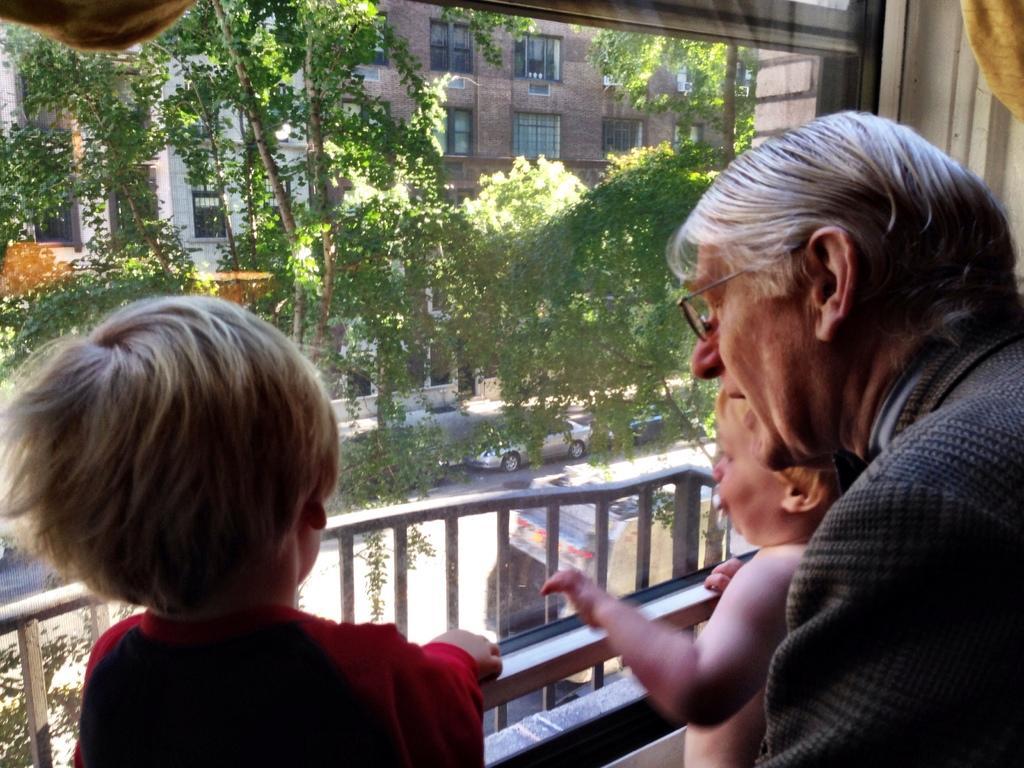In one or two sentences, can you explain what this image depicts? In this image we can see there is a person and two kids looking the outside view from the window. From the window we can see there is a railing in front of the window and there are two cars moving on the road, tree and buildings. 